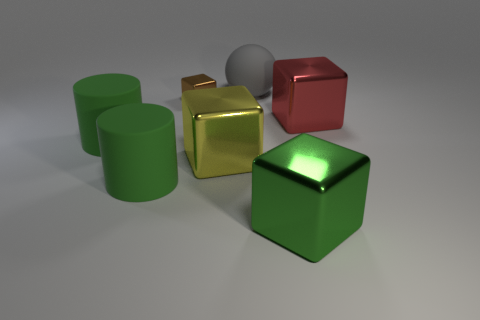Subtract all cyan blocks. Subtract all cyan spheres. How many blocks are left? 4 Add 1 brown metal blocks. How many objects exist? 8 Add 7 big gray matte spheres. How many big gray matte spheres are left? 8 Add 1 yellow rubber cylinders. How many yellow rubber cylinders exist? 1 Subtract 0 blue balls. How many objects are left? 7 Subtract all cylinders. How many objects are left? 5 Subtract all big gray things. Subtract all gray matte balls. How many objects are left? 5 